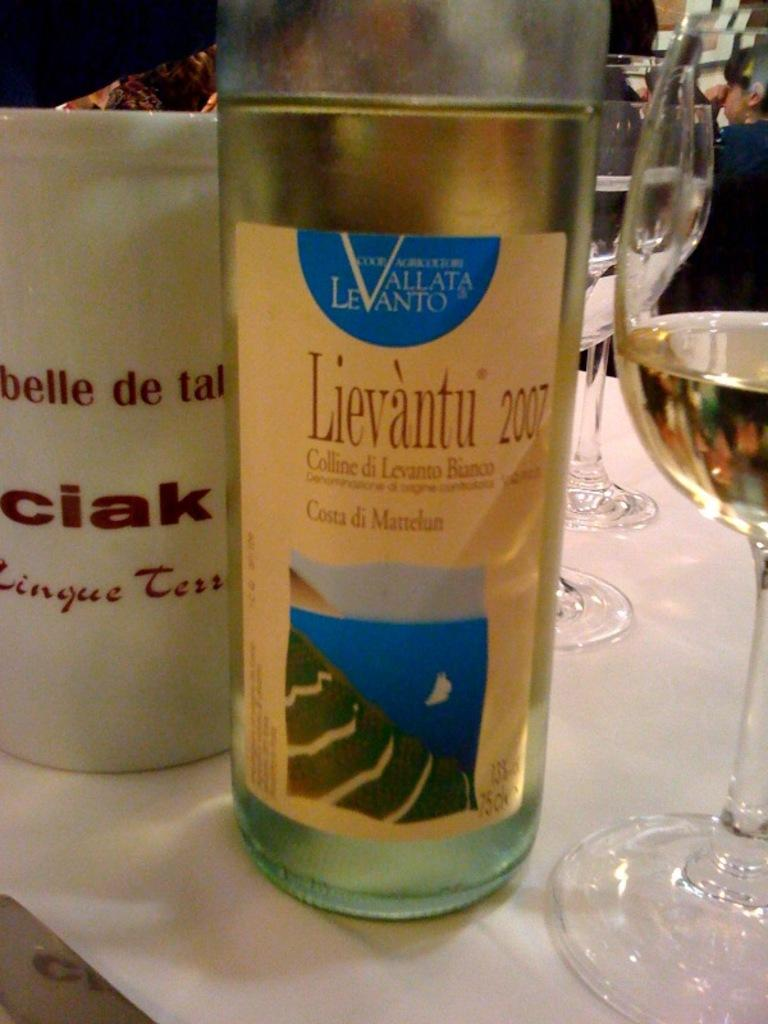<image>
Create a compact narrative representing the image presented. A clear glass bottle of Lievantu wine from 2007 with white label with an illustrated ocean scene. 